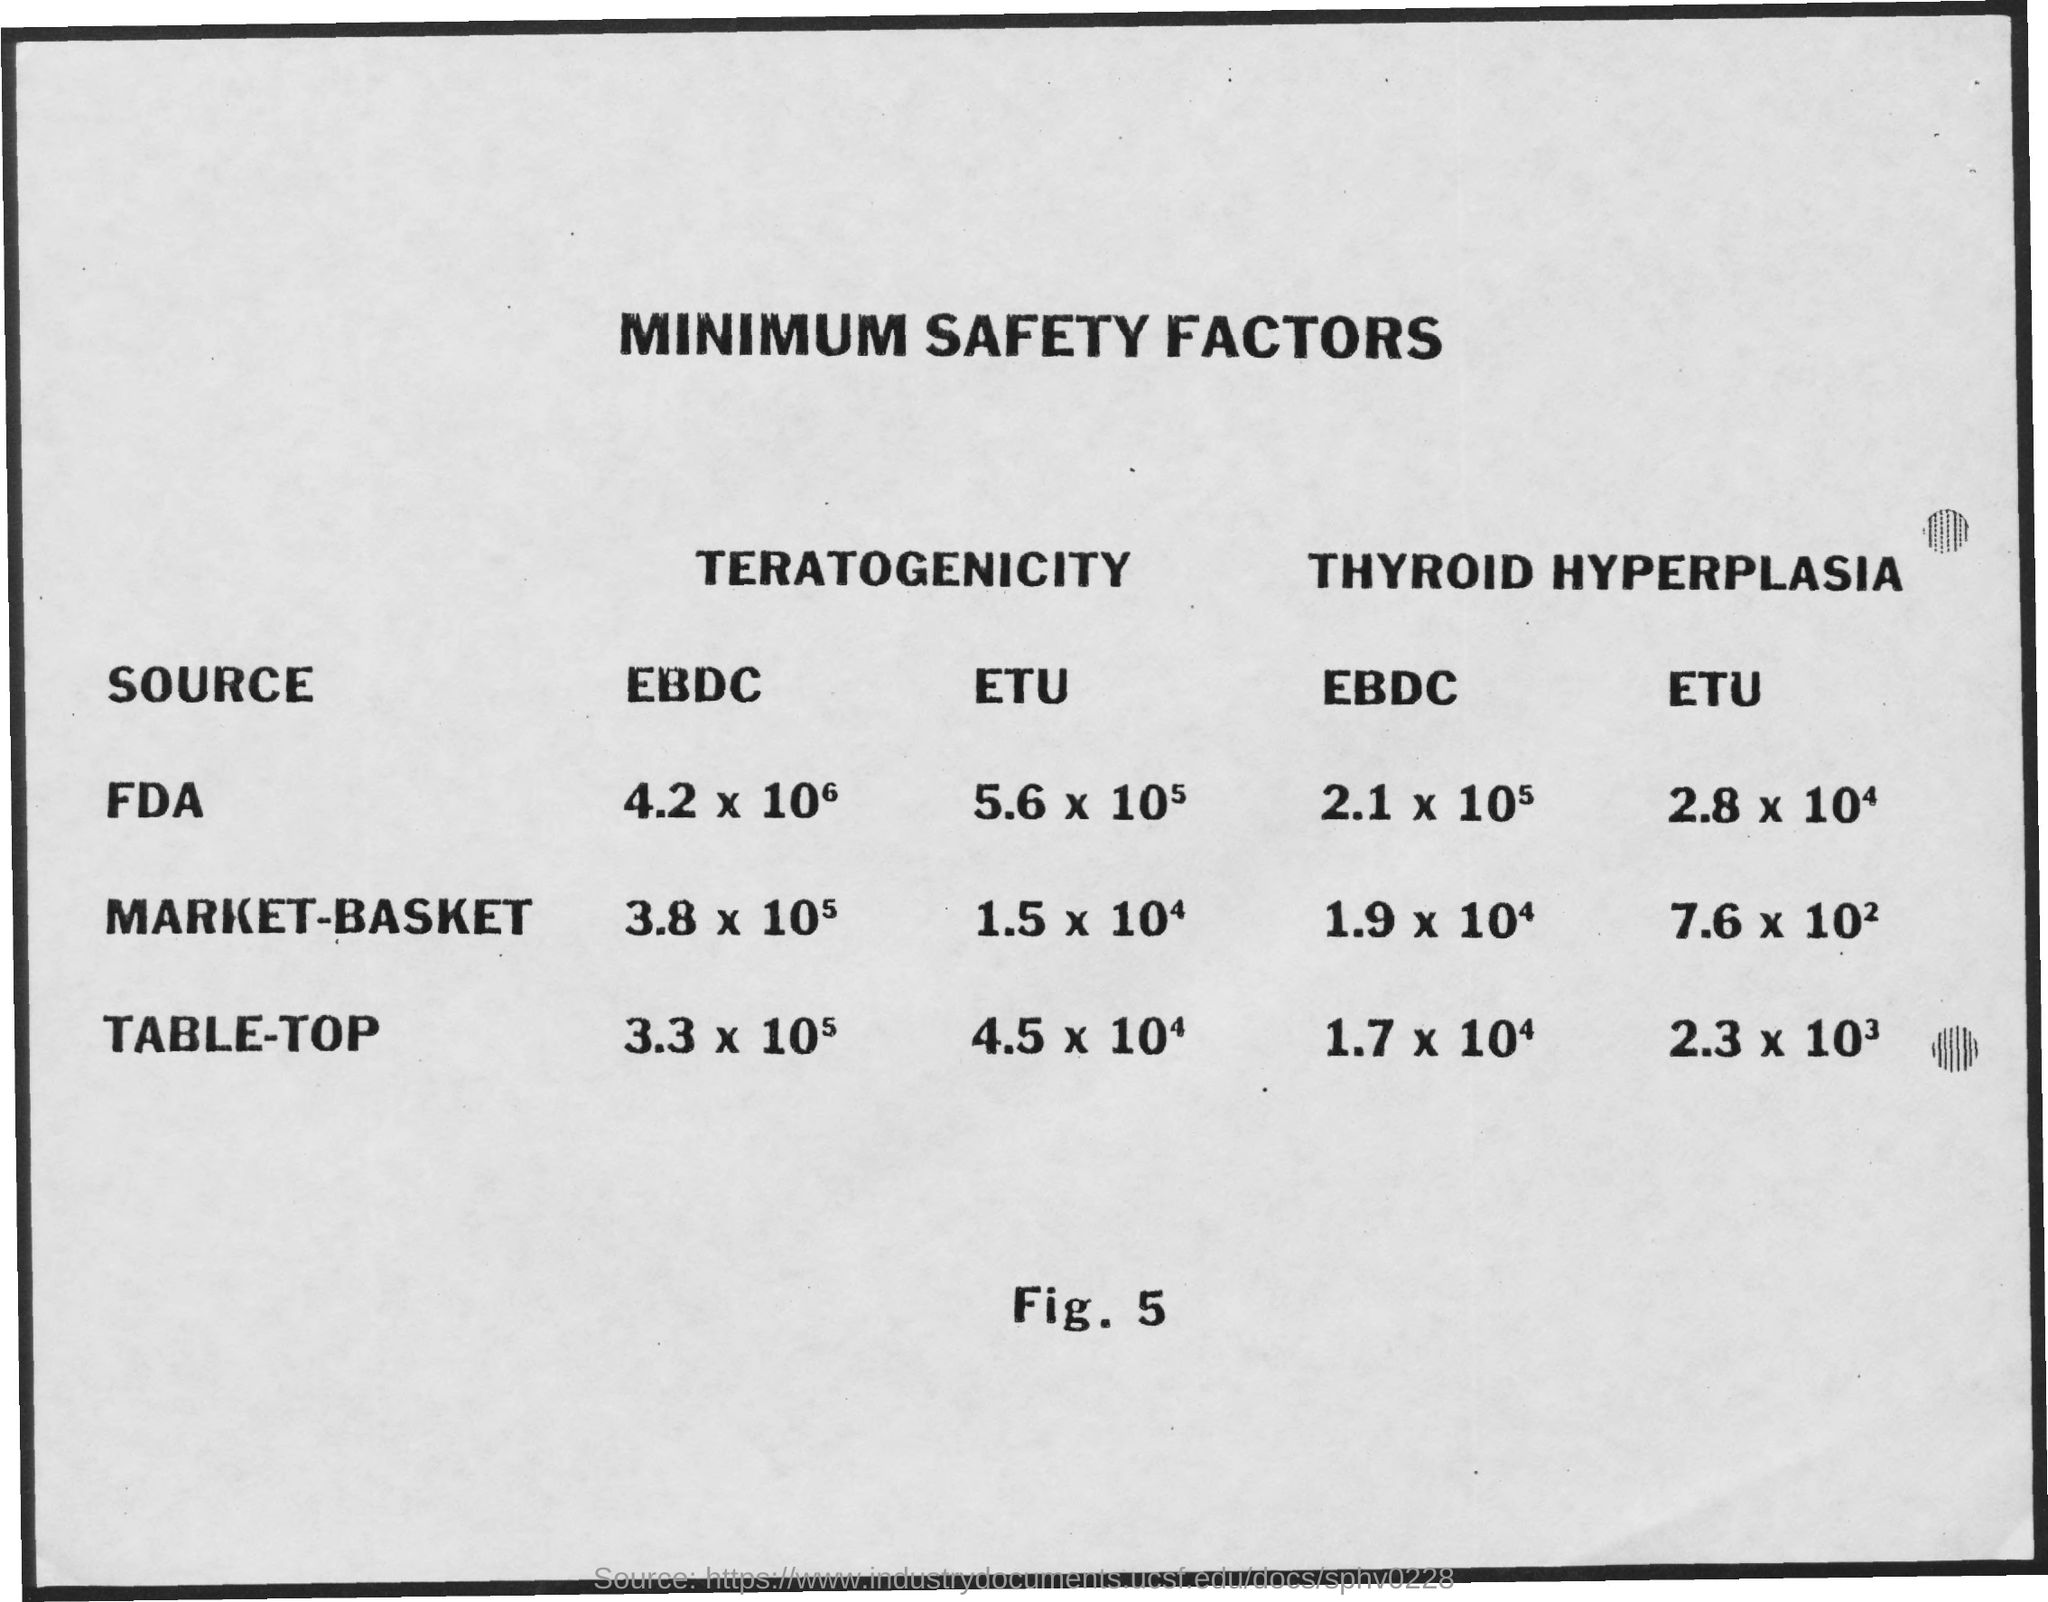What is the Title of the document?
Ensure brevity in your answer.  Minimum Safety Factors. 